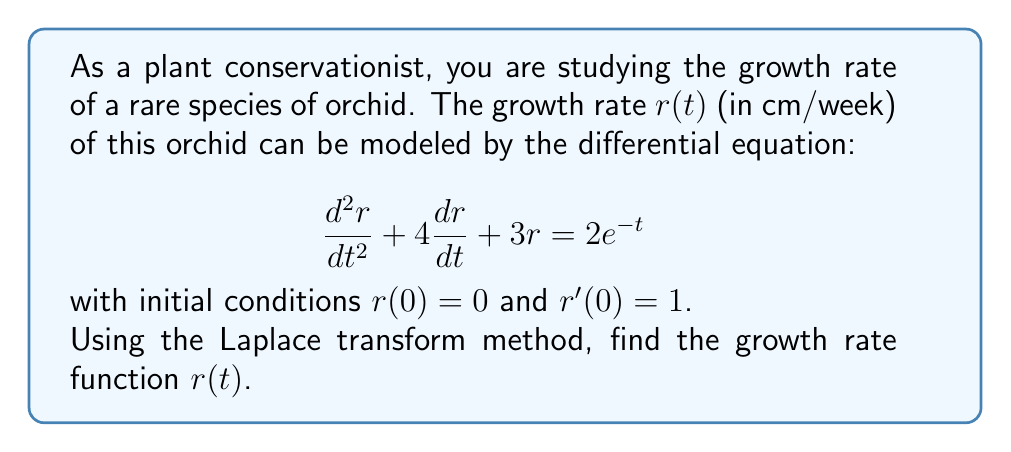Teach me how to tackle this problem. Let's solve this step-by-step using the Laplace transform method:

1) Take the Laplace transform of both sides of the equation:
   $$\mathcal{L}\left\{\frac{d^2r}{dt^2} + 4\frac{dr}{dt} + 3r\right\} = \mathcal{L}\{2e^{-t}\}$$

2) Using Laplace transform properties:
   $$s^2R(s) - sr(0) - r'(0) + 4[sR(s) - r(0)] + 3R(s) = \frac{2}{s+1}$$

3) Substitute the initial conditions $r(0) = 0$ and $r'(0) = 1$:
   $$s^2R(s) - 1 + 4sR(s) + 3R(s) = \frac{2}{s+1}$$

4) Simplify:
   $$R(s)(s^2 + 4s + 3) = \frac{2}{s+1} + 1$$

5) Factor the left side:
   $$R(s)(s + 1)(s + 3) = \frac{2}{s+1} + 1$$

6) Multiply both sides by $(s+1)$:
   $$R(s)(s + 1)^2(s + 3) = 2 + (s+1)$$

7) Divide both sides by $(s + 1)^2(s + 3)$:
   $$R(s) = \frac{2 + (s+1)}{(s + 1)^2(s + 3)}$$

8) Perform partial fraction decomposition:
   $$R(s) = \frac{A}{s+1} + \frac{B}{(s+1)^2} + \frac{C}{s+3}$$

9) Solve for A, B, and C:
   $$A = -\frac{1}{4}, B = \frac{5}{4}, C = \frac{1}{4}$$

10) Rewrite R(s):
    $$R(s) = -\frac{1}{4(s+1)} + \frac{5}{4(s+1)^2} + \frac{1}{4(s+3)}$$

11) Take the inverse Laplace transform:
    $$r(t) = -\frac{1}{4}e^{-t} + \frac{5}{4}te^{-t} + \frac{1}{4}e^{-3t}$$

This is the growth rate function $r(t)$.
Answer: $r(t) = -\frac{1}{4}e^{-t} + \frac{5}{4}te^{-t} + \frac{1}{4}e^{-3t}$ 